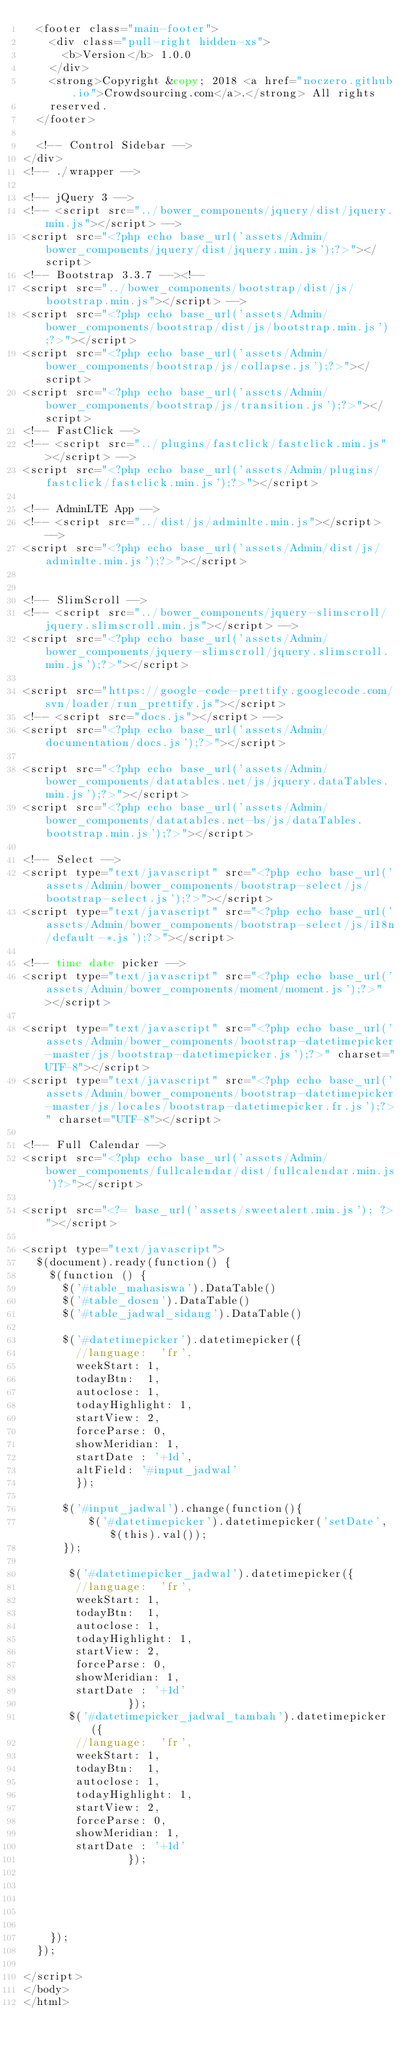<code> <loc_0><loc_0><loc_500><loc_500><_PHP_>  <footer class="main-footer">
    <div class="pull-right hidden-xs">
      <b>Version</b> 1.0.0
    </div>
    <strong>Copyright &copy; 2018 <a href="noczero.github.io">Crowdsourcing.com</a>.</strong> All rights
    reserved.
  </footer>

  <!-- Control Sidebar -->
</div>
<!-- ./wrapper -->

<!-- jQuery 3 -->
<!-- <script src="../bower_components/jquery/dist/jquery.min.js"></script> -->
<script src="<?php echo base_url('assets/Admin/bower_components/jquery/dist/jquery.min.js');?>"></script>
<!-- Bootstrap 3.3.7 --><!--
<script src="../bower_components/bootstrap/dist/js/bootstrap.min.js"></script> -->
<script src="<?php echo base_url('assets/Admin/bower_components/bootstrap/dist/js/bootstrap.min.js');?>"></script>
<script src="<?php echo base_url('assets/Admin/bower_components/bootstrap/js/collapse.js');?>"></script>
<script src="<?php echo base_url('assets/Admin/bower_components/bootstrap/js/transition.js');?>"></script>
<!-- FastClick -->
<!-- <script src="../plugins/fastclick/fastclick.min.js"></script> -->
<script src="<?php echo base_url('assets/Admin/plugins/fastclick/fastclick.min.js');?>"></script>

<!-- AdminLTE App -->
<!-- <script src="../dist/js/adminlte.min.js"></script> -->
<script src="<?php echo base_url('assets/Admin/dist/js/adminlte.min.js');?>"></script>


<!-- SlimScroll -->
<!-- <script src="../bower_components/jquery-slimscroll/jquery.slimscroll.min.js"></script> -->
<script src="<?php echo base_url('assets/Admin/bower_components/jquery-slimscroll/jquery.slimscroll.min.js');?>"></script>

<script src="https://google-code-prettify.googlecode.com/svn/loader/run_prettify.js"></script>
<!-- <script src="docs.js"></script> -->
<script src="<?php echo base_url('assets/Admin/documentation/docs.js');?>"></script>

<script src="<?php echo base_url('assets/Admin/bower_components/datatables.net/js/jquery.dataTables.min.js');?>"></script>
<script src="<?php echo base_url('assets/Admin/bower_components/datatables.net-bs/js/dataTables.bootstrap.min.js');?>"></script>

<!-- Select -->
<script type="text/javascript" src="<?php echo base_url('assets/Admin/bower_components/bootstrap-select/js/bootstrap-select.js');?>"></script>
<script type="text/javascript" src="<?php echo base_url('assets/Admin/bower_components/bootstrap-select/js/i18n/default-*.js');?>"></script>

<!-- time date picker -->
<script type="text/javascript" src="<?php echo base_url('assets/Admin/bower_components/moment/moment.js');?>"></script>

<script type="text/javascript" src="<?php echo base_url('assets/Admin/bower_components/bootstrap-datetimepicker-master/js/bootstrap-datetimepicker.js');?>" charset="UTF-8"></script>
<script type="text/javascript" src="<?php echo base_url('assets/Admin/bower_components/bootstrap-datetimepicker-master/js/locales/bootstrap-datetimepicker.fr.js');?>" charset="UTF-8"></script>

<!-- Full Calendar -->
<script src="<?php echo base_url('assets/Admin/bower_components/fullcalendar/dist/fullcalendar.min.js')?>"></script>

<script src="<?= base_url('assets/sweetalert.min.js'); ?>"></script>

<script type="text/javascript">
  $(document).ready(function() {
    $(function () {
      $('#table_mahasiswa').DataTable()
      $('#table_dosen').DataTable()
      $('#table_jadwal_sidang').DataTable()

      $('#datetimepicker').datetimepicker({
        //language:  'fr',
        weekStart: 1,
        todayBtn:  1,
        autoclose: 1,
        todayHighlight: 1,
        startView: 2,
        forceParse: 0,
        showMeridian: 1,
        startDate : '+1d',
        altField: '#input_jadwal'
        });

      $('#input_jadwal').change(function(){
          $('#datetimepicker').datetimepicker('setDate', $(this).val());
      });

       $('#datetimepicker_jadwal').datetimepicker({
        //language:  'fr',
        weekStart: 1,
        todayBtn:  1,
        autoclose: 1,
        todayHighlight: 1,
        startView: 2,
        forceParse: 0,
        showMeridian: 1,
        startDate : '+1d'
                });
       $('#datetimepicker_jadwal_tambah').datetimepicker({
        //language:  'fr',
        weekStart: 1,
        todayBtn:  1,
        autoclose: 1,
        todayHighlight: 1,
        startView: 2,
        forceParse: 0,
        showMeridian: 1,
        startDate : '+1d'
                });





    });
  });

</script>
</body>
</html>
</code> 